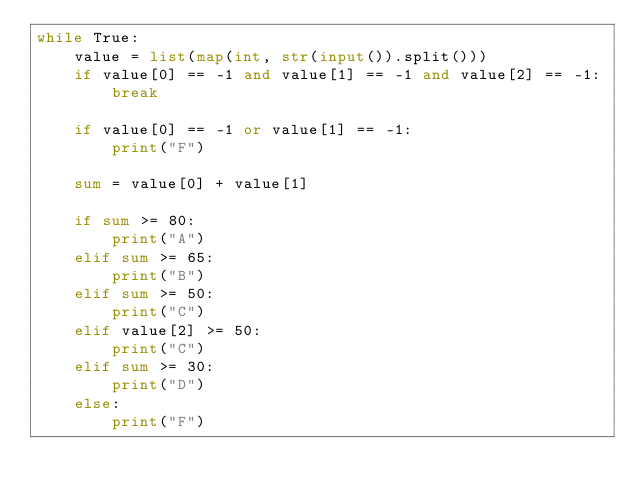Convert code to text. <code><loc_0><loc_0><loc_500><loc_500><_Python_>while True:
    value = list(map(int, str(input()).split()))
    if value[0] == -1 and value[1] == -1 and value[2] == -1:
        break

    if value[0] == -1 or value[1] == -1:
        print("F")

    sum = value[0] + value[1]

    if sum >= 80:
        print("A")
    elif sum >= 65:
        print("B")
    elif sum >= 50:
        print("C")
    elif value[2] >= 50:
        print("C")
    elif sum >= 30:
        print("D")
    else:
        print("F")



</code> 